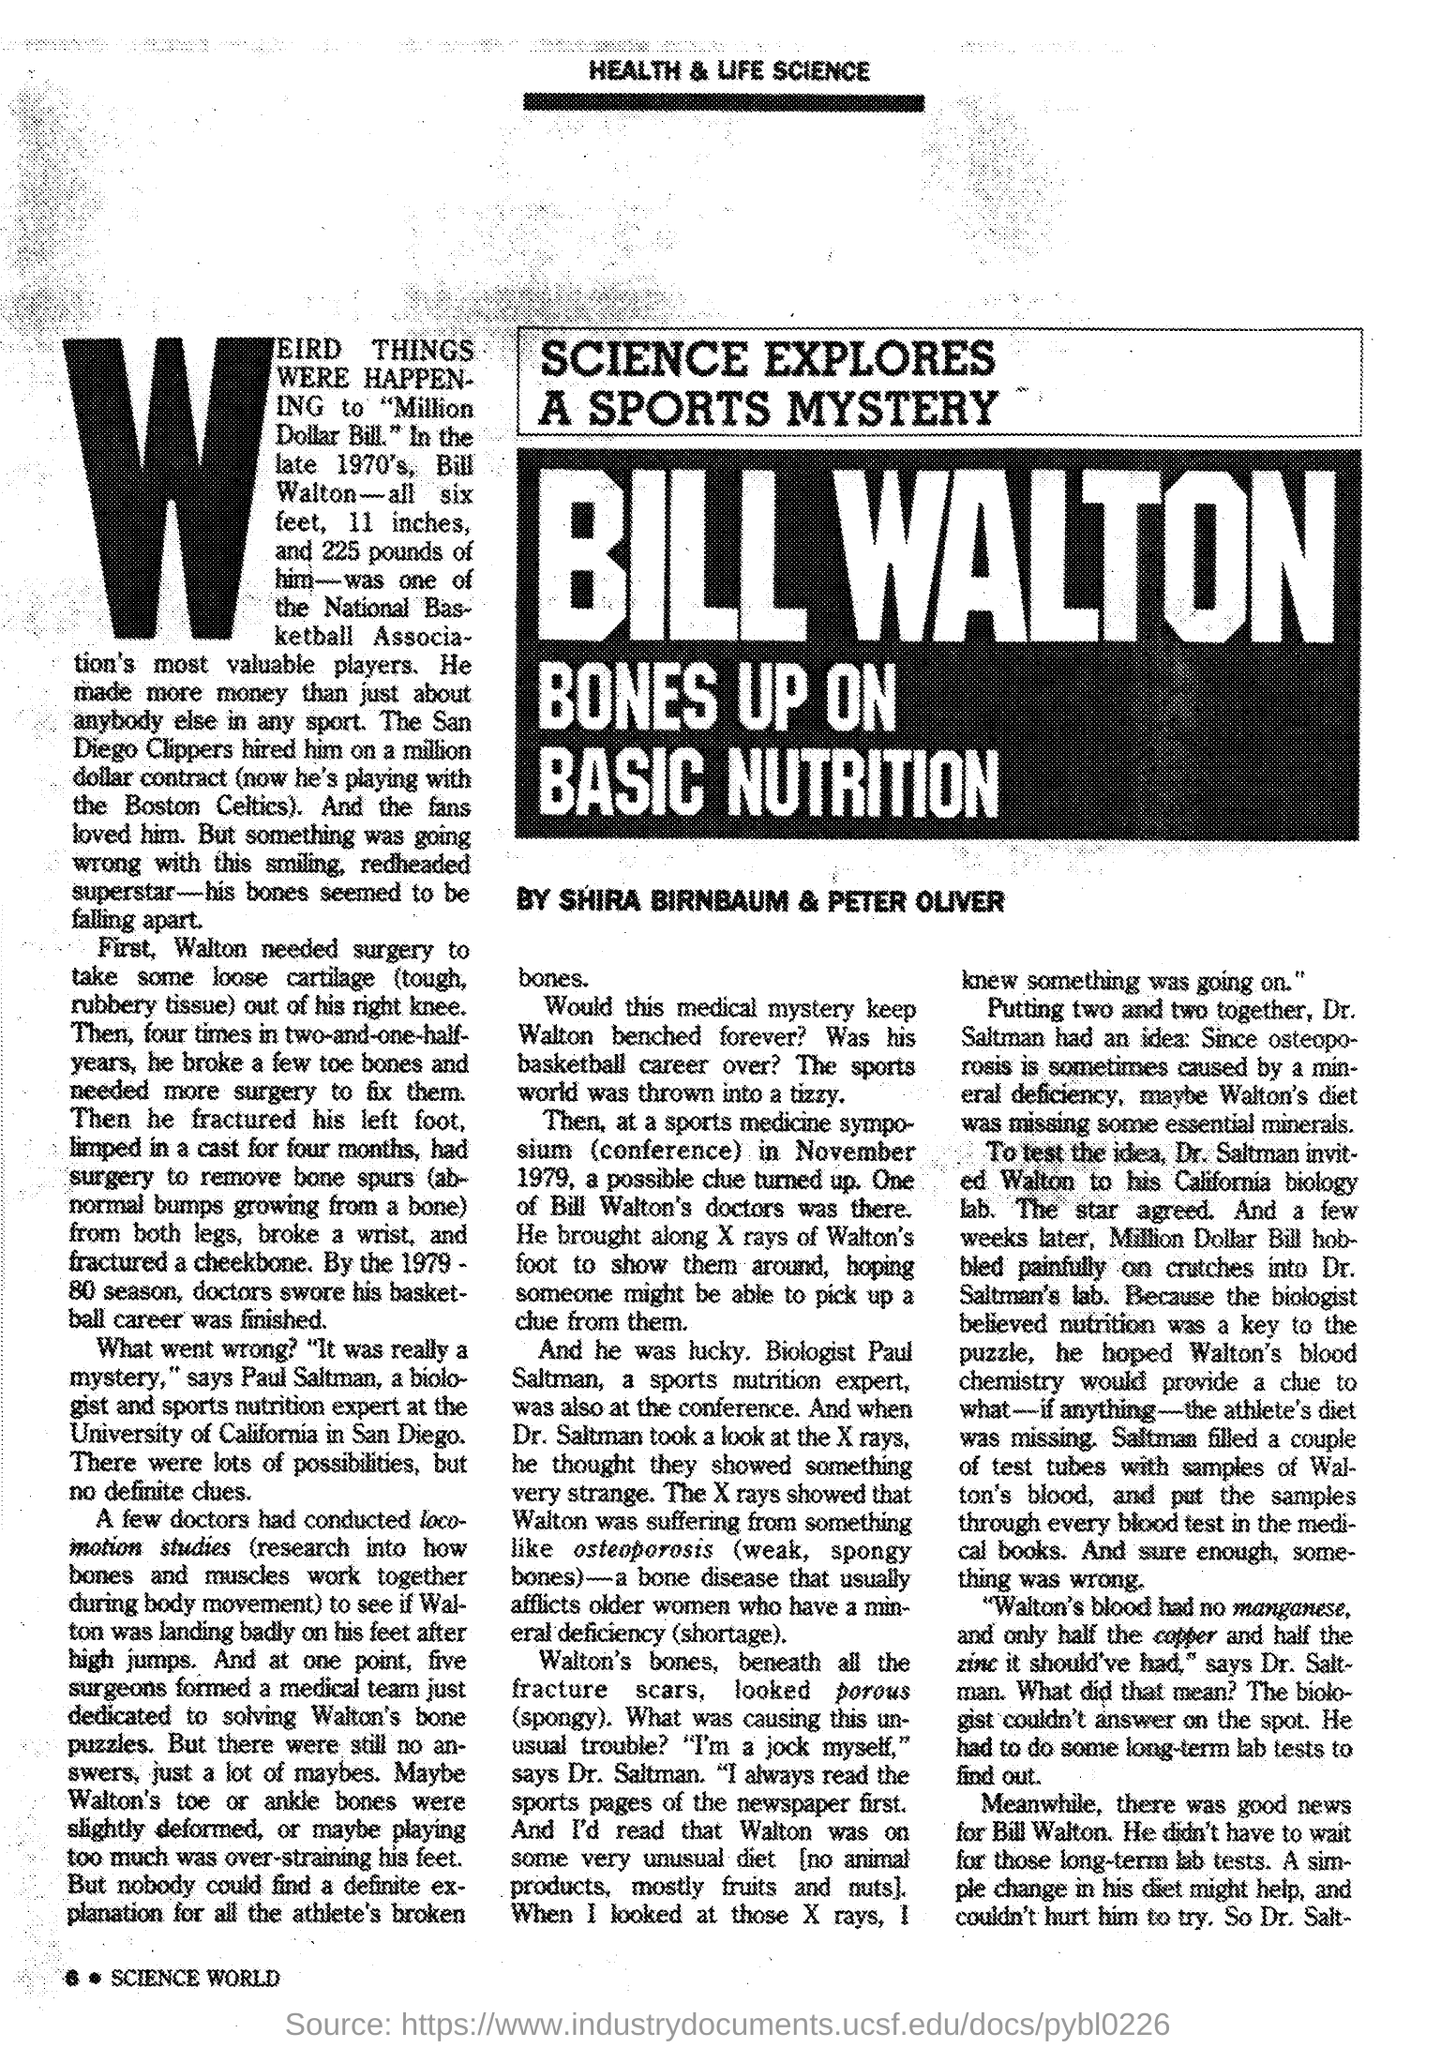Mention a couple of crucial points in this snapshot. Shira Birnbaum and Peter Oliver submitted the report. The page number is 6. 